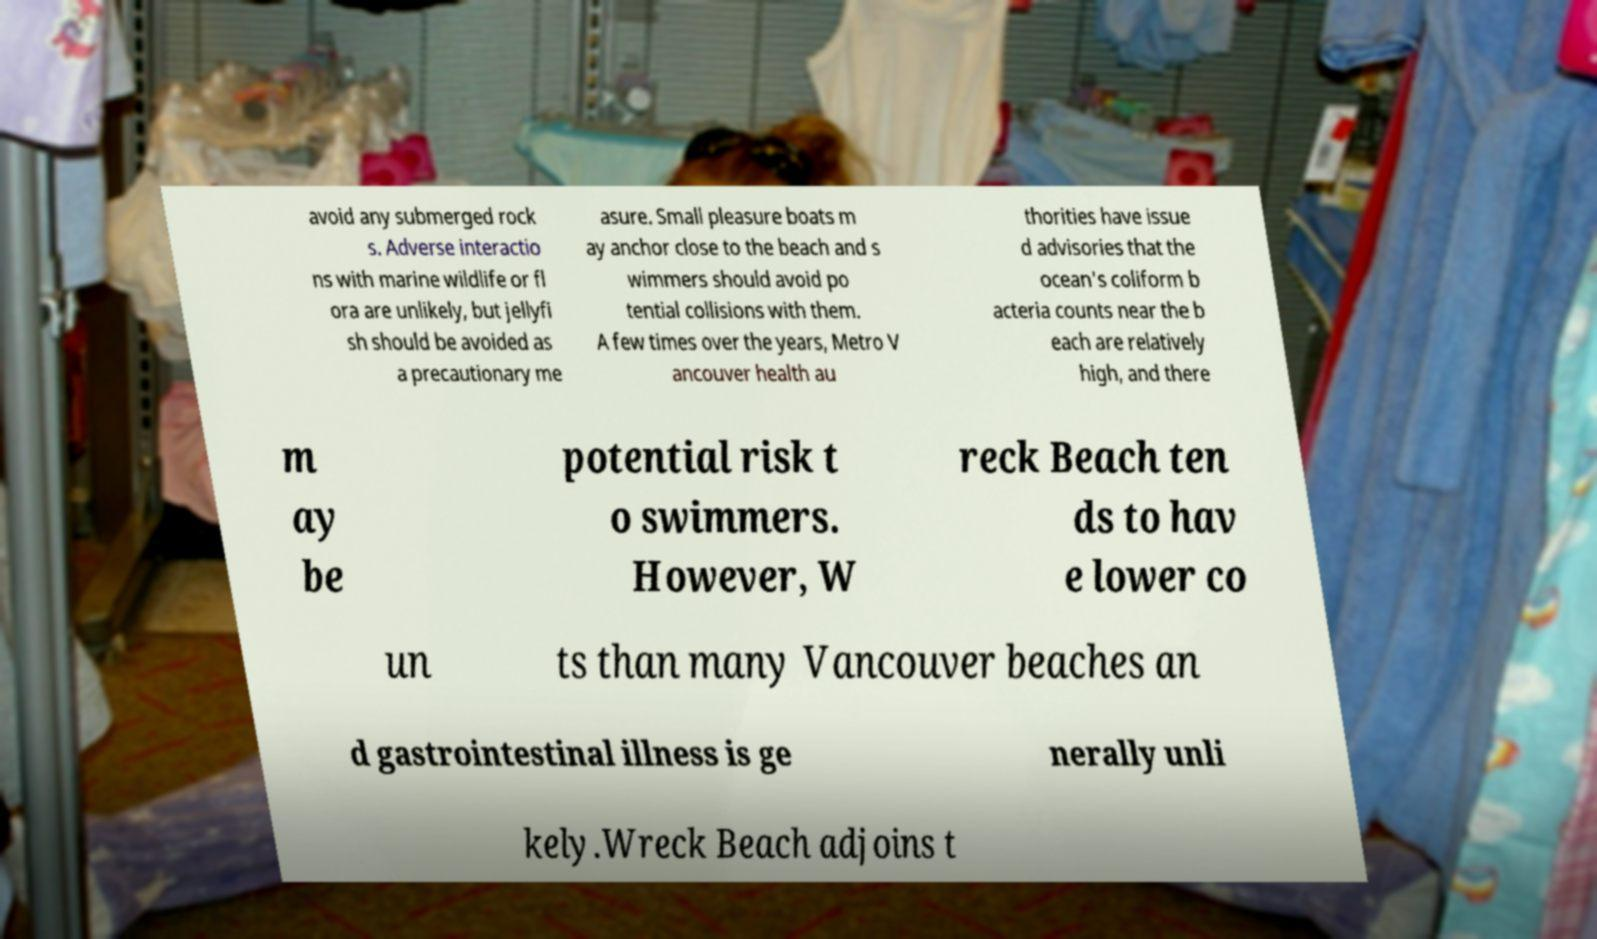Can you read and provide the text displayed in the image?This photo seems to have some interesting text. Can you extract and type it out for me? avoid any submerged rock s. Adverse interactio ns with marine wildlife or fl ora are unlikely, but jellyfi sh should be avoided as a precautionary me asure. Small pleasure boats m ay anchor close to the beach and s wimmers should avoid po tential collisions with them. A few times over the years, Metro V ancouver health au thorities have issue d advisories that the ocean's coliform b acteria counts near the b each are relatively high, and there m ay be potential risk t o swimmers. However, W reck Beach ten ds to hav e lower co un ts than many Vancouver beaches an d gastrointestinal illness is ge nerally unli kely.Wreck Beach adjoins t 